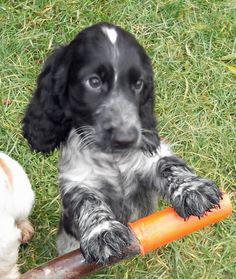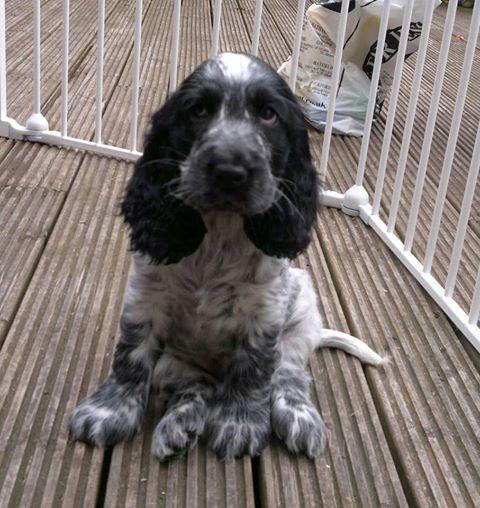The first image is the image on the left, the second image is the image on the right. Evaluate the accuracy of this statement regarding the images: "An image shows one dog interacting with a stick-shaped item that is at least partly brown.". Is it true? Answer yes or no. Yes. The first image is the image on the left, the second image is the image on the right. Assess this claim about the two images: "The dog in the image on the left is lying on the grass.". Correct or not? Answer yes or no. No. 